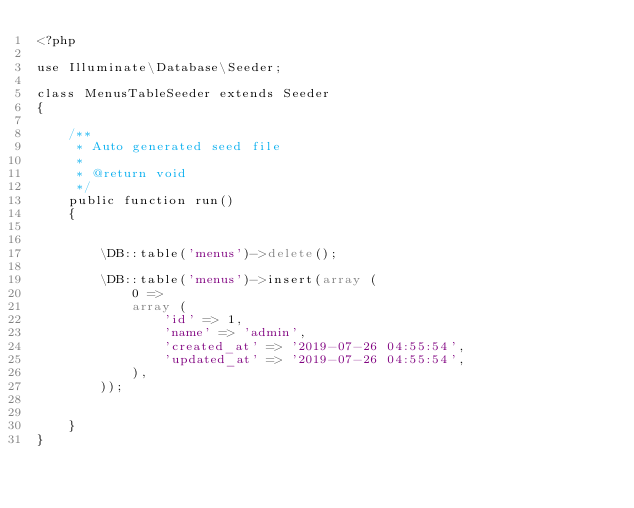Convert code to text. <code><loc_0><loc_0><loc_500><loc_500><_PHP_><?php

use Illuminate\Database\Seeder;

class MenusTableSeeder extends Seeder
{

    /**
     * Auto generated seed file
     *
     * @return void
     */
    public function run()
    {
        

        \DB::table('menus')->delete();
        
        \DB::table('menus')->insert(array (
            0 => 
            array (
                'id' => 1,
                'name' => 'admin',
                'created_at' => '2019-07-26 04:55:54',
                'updated_at' => '2019-07-26 04:55:54',
            ),
        ));
        
        
    }
}</code> 